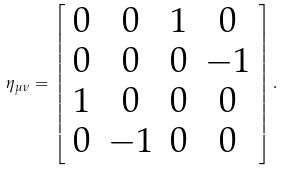Convert formula to latex. <formula><loc_0><loc_0><loc_500><loc_500>\eta _ { \mu \nu } = \left [ \begin{array} { c c c c } 0 & 0 & 1 & 0 \\ 0 & 0 & 0 & - 1 \\ 1 & 0 & 0 & 0 \\ 0 & - 1 & 0 & 0 \end{array} \right ] .</formula> 